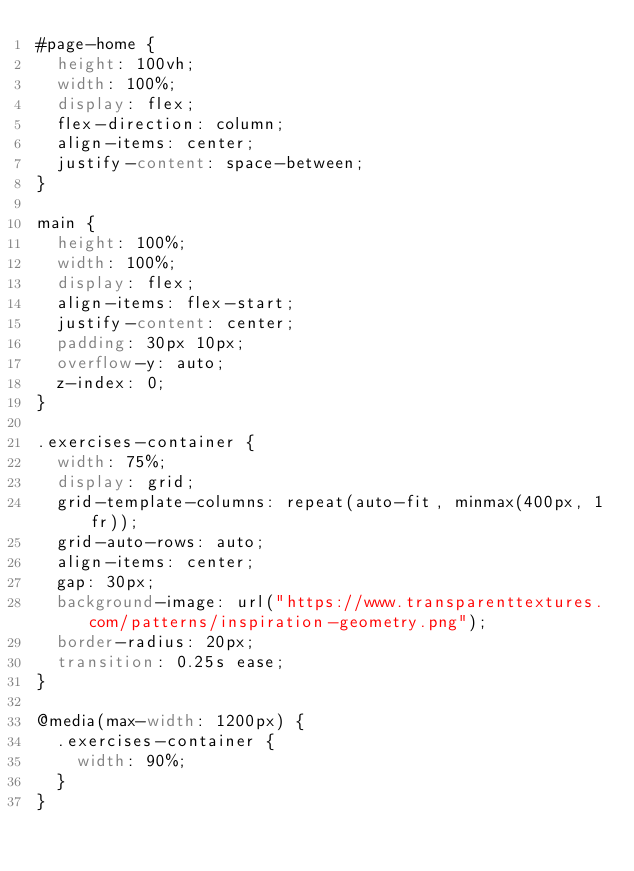Convert code to text. <code><loc_0><loc_0><loc_500><loc_500><_CSS_>#page-home {
  height: 100vh;
  width: 100%;
  display: flex;
  flex-direction: column;
  align-items: center;
  justify-content: space-between;
}

main {
  height: 100%;
  width: 100%;
  display: flex;
  align-items: flex-start;
  justify-content: center;
  padding: 30px 10px;
  overflow-y: auto;
  z-index: 0;
}

.exercises-container {
  width: 75%;
  display: grid;
  grid-template-columns: repeat(auto-fit, minmax(400px, 1fr));
  grid-auto-rows: auto;
  align-items: center;
  gap: 30px;
  background-image: url("https://www.transparenttextures.com/patterns/inspiration-geometry.png");
  border-radius: 20px;
  transition: 0.25s ease;
}

@media(max-width: 1200px) {
  .exercises-container {
    width: 90%;
  }
}</code> 